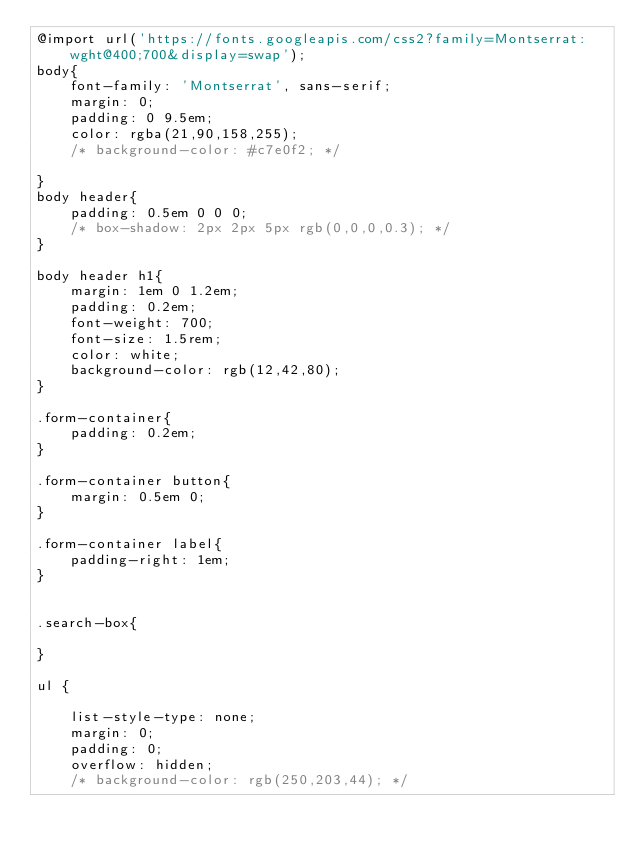<code> <loc_0><loc_0><loc_500><loc_500><_CSS_>@import url('https://fonts.googleapis.com/css2?family=Montserrat:wght@400;700&display=swap');
body{
    font-family: 'Montserrat', sans-serif;
    margin: 0;
    padding: 0 9.5em;
    color: rgba(21,90,158,255);
    /* background-color: #c7e0f2; */

}
body header{
    padding: 0.5em 0 0 0;
    /* box-shadow: 2px 2px 5px rgb(0,0,0,0.3); */
}

body header h1{
    margin: 1em 0 1.2em;
    padding: 0.2em;
    font-weight: 700;
    font-size: 1.5rem;
    color: white;
    background-color: rgb(12,42,80);
}

.form-container{
    padding: 0.2em; 
}

.form-container button{
    margin: 0.5em 0;
}

.form-container label{
    padding-right: 1em;
}


.search-box{

}

ul {

    list-style-type: none;
    margin: 0;
    padding: 0;
    overflow: hidden;
    /* background-color: rgb(250,203,44); */</code> 